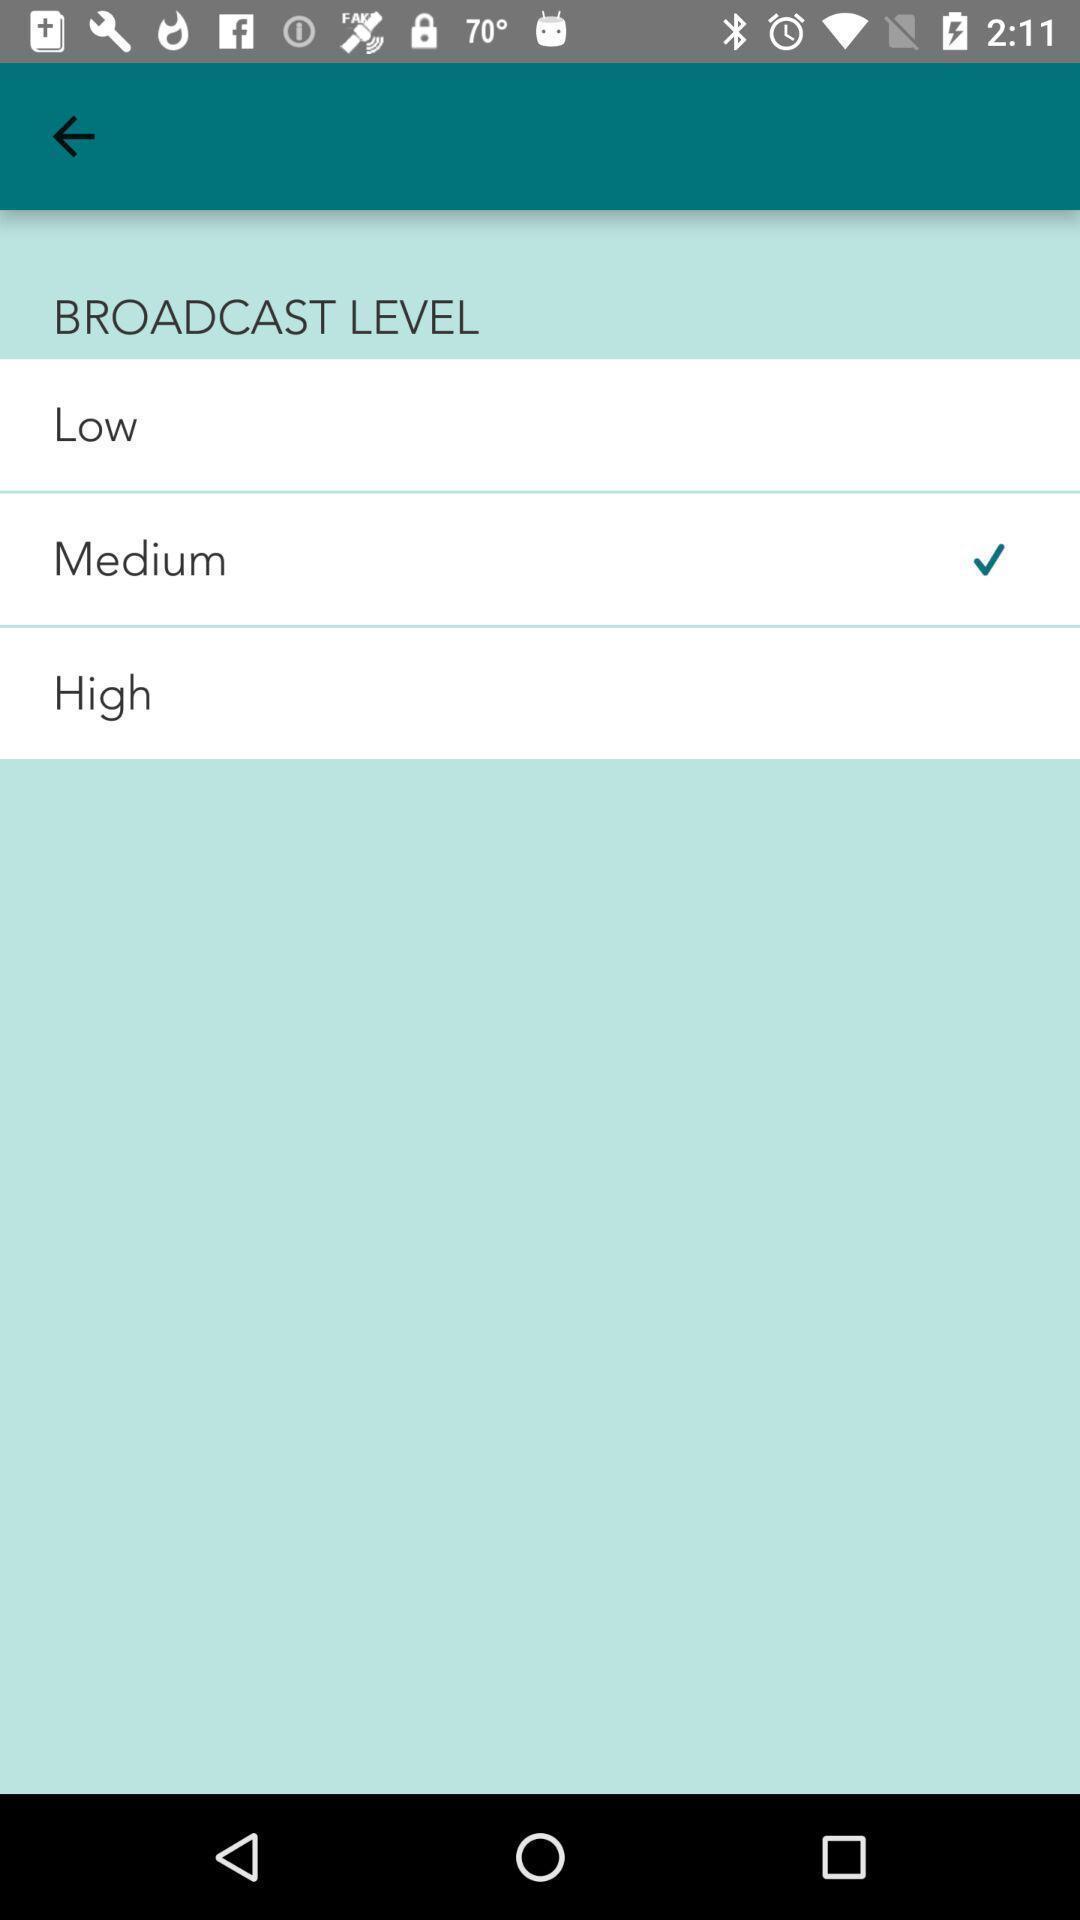Give me a narrative description of this picture. Page showing about different broadcast level. 